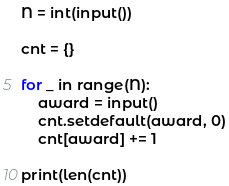<code> <loc_0><loc_0><loc_500><loc_500><_Python_>N = int(input())

cnt = {}

for _ in range(N):
    award = input()
    cnt.setdefault(award, 0)
    cnt[award] += 1
    
print(len(cnt))</code> 